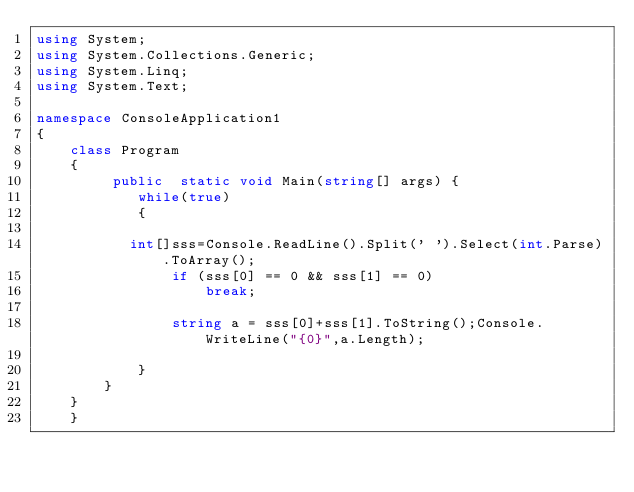<code> <loc_0><loc_0><loc_500><loc_500><_C#_>using System;
using System.Collections.Generic;
using System.Linq;
using System.Text;

namespace ConsoleApplication1
{   
    class Program
    {
         public  static void Main(string[] args) {
            while(true)
            {

           int[]sss=Console.ReadLine().Split(' ').Select(int.Parse).ToArray();
                if (sss[0] == 0 && sss[1] == 0)
                    break;

                string a = sss[0]+sss[1].ToString();Console.WriteLine("{0}",a.Length);

            }
        }
    }
    }</code> 